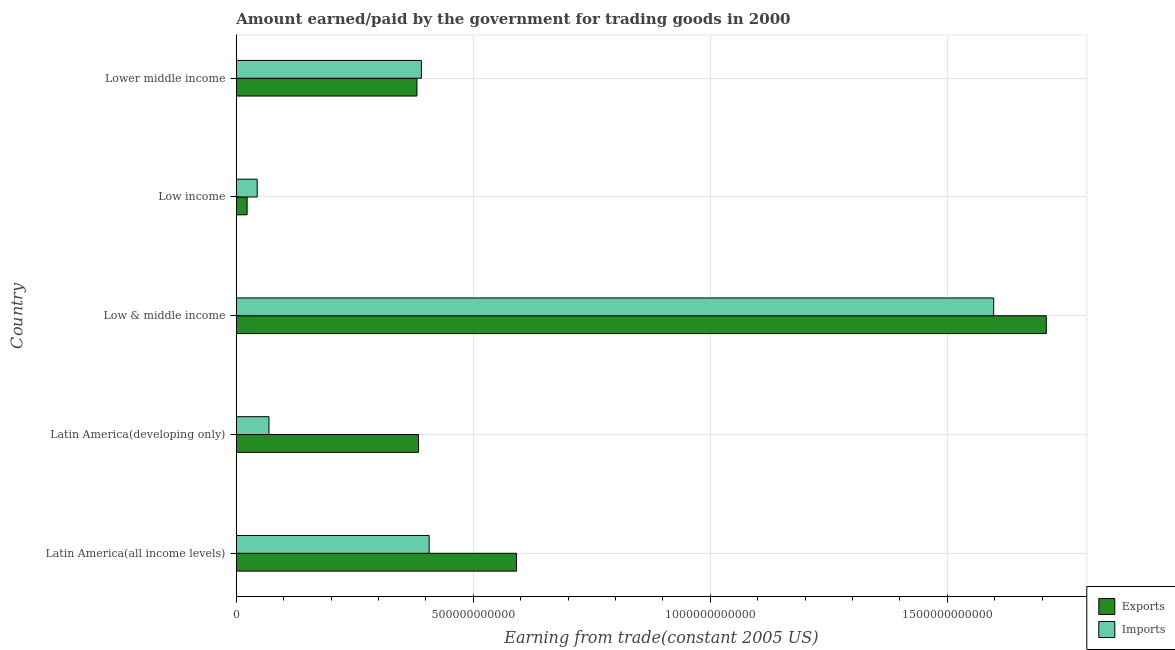How many different coloured bars are there?
Make the answer very short. 2. Are the number of bars on each tick of the Y-axis equal?
Offer a very short reply. Yes. How many bars are there on the 2nd tick from the top?
Provide a succinct answer. 2. How many bars are there on the 5th tick from the bottom?
Offer a very short reply. 2. What is the label of the 1st group of bars from the top?
Ensure brevity in your answer.  Lower middle income. What is the amount earned from exports in Latin America(all income levels)?
Offer a terse response. 5.91e+11. Across all countries, what is the maximum amount earned from exports?
Offer a terse response. 1.71e+12. Across all countries, what is the minimum amount paid for imports?
Your answer should be compact. 4.42e+1. In which country was the amount paid for imports maximum?
Keep it short and to the point. Low & middle income. What is the total amount paid for imports in the graph?
Ensure brevity in your answer.  2.51e+12. What is the difference between the amount earned from exports in Low & middle income and that in Low income?
Provide a short and direct response. 1.69e+12. What is the difference between the amount paid for imports in Low & middle income and the amount earned from exports in Latin America(developing only)?
Ensure brevity in your answer.  1.21e+12. What is the average amount paid for imports per country?
Keep it short and to the point. 5.02e+11. What is the difference between the amount paid for imports and amount earned from exports in Lower middle income?
Your answer should be very brief. 9.44e+09. What is the ratio of the amount earned from exports in Latin America(all income levels) to that in Low & middle income?
Offer a terse response. 0.35. What is the difference between the highest and the second highest amount earned from exports?
Provide a succinct answer. 1.12e+12. What is the difference between the highest and the lowest amount paid for imports?
Offer a very short reply. 1.55e+12. In how many countries, is the amount paid for imports greater than the average amount paid for imports taken over all countries?
Make the answer very short. 1. Is the sum of the amount earned from exports in Latin America(all income levels) and Low income greater than the maximum amount paid for imports across all countries?
Make the answer very short. No. What does the 1st bar from the top in Latin America(developing only) represents?
Offer a terse response. Imports. What does the 1st bar from the bottom in Low & middle income represents?
Your answer should be very brief. Exports. How many bars are there?
Your answer should be compact. 10. How many countries are there in the graph?
Your answer should be compact. 5. What is the difference between two consecutive major ticks on the X-axis?
Your answer should be very brief. 5.00e+11. Are the values on the major ticks of X-axis written in scientific E-notation?
Your response must be concise. No. How many legend labels are there?
Give a very brief answer. 2. How are the legend labels stacked?
Your answer should be very brief. Vertical. What is the title of the graph?
Keep it short and to the point. Amount earned/paid by the government for trading goods in 2000. Does "Old" appear as one of the legend labels in the graph?
Keep it short and to the point. No. What is the label or title of the X-axis?
Offer a terse response. Earning from trade(constant 2005 US). What is the label or title of the Y-axis?
Keep it short and to the point. Country. What is the Earning from trade(constant 2005 US) of Exports in Latin America(all income levels)?
Your answer should be very brief. 5.91e+11. What is the Earning from trade(constant 2005 US) in Imports in Latin America(all income levels)?
Offer a terse response. 4.07e+11. What is the Earning from trade(constant 2005 US) in Exports in Latin America(developing only)?
Ensure brevity in your answer.  3.84e+11. What is the Earning from trade(constant 2005 US) of Imports in Latin America(developing only)?
Provide a succinct answer. 6.90e+1. What is the Earning from trade(constant 2005 US) of Exports in Low & middle income?
Provide a short and direct response. 1.71e+12. What is the Earning from trade(constant 2005 US) of Imports in Low & middle income?
Provide a succinct answer. 1.60e+12. What is the Earning from trade(constant 2005 US) in Exports in Low income?
Your response must be concise. 2.29e+1. What is the Earning from trade(constant 2005 US) in Imports in Low income?
Your answer should be very brief. 4.42e+1. What is the Earning from trade(constant 2005 US) in Exports in Lower middle income?
Offer a very short reply. 3.81e+11. What is the Earning from trade(constant 2005 US) of Imports in Lower middle income?
Give a very brief answer. 3.91e+11. Across all countries, what is the maximum Earning from trade(constant 2005 US) of Exports?
Make the answer very short. 1.71e+12. Across all countries, what is the maximum Earning from trade(constant 2005 US) in Imports?
Your response must be concise. 1.60e+12. Across all countries, what is the minimum Earning from trade(constant 2005 US) in Exports?
Ensure brevity in your answer.  2.29e+1. Across all countries, what is the minimum Earning from trade(constant 2005 US) of Imports?
Your response must be concise. 4.42e+1. What is the total Earning from trade(constant 2005 US) in Exports in the graph?
Make the answer very short. 3.09e+12. What is the total Earning from trade(constant 2005 US) of Imports in the graph?
Give a very brief answer. 2.51e+12. What is the difference between the Earning from trade(constant 2005 US) of Exports in Latin America(all income levels) and that in Latin America(developing only)?
Offer a terse response. 2.07e+11. What is the difference between the Earning from trade(constant 2005 US) of Imports in Latin America(all income levels) and that in Latin America(developing only)?
Ensure brevity in your answer.  3.38e+11. What is the difference between the Earning from trade(constant 2005 US) of Exports in Latin America(all income levels) and that in Low & middle income?
Give a very brief answer. -1.12e+12. What is the difference between the Earning from trade(constant 2005 US) in Imports in Latin America(all income levels) and that in Low & middle income?
Your answer should be compact. -1.19e+12. What is the difference between the Earning from trade(constant 2005 US) in Exports in Latin America(all income levels) and that in Low income?
Ensure brevity in your answer.  5.68e+11. What is the difference between the Earning from trade(constant 2005 US) in Imports in Latin America(all income levels) and that in Low income?
Give a very brief answer. 3.63e+11. What is the difference between the Earning from trade(constant 2005 US) of Exports in Latin America(all income levels) and that in Lower middle income?
Your answer should be compact. 2.10e+11. What is the difference between the Earning from trade(constant 2005 US) in Imports in Latin America(all income levels) and that in Lower middle income?
Provide a succinct answer. 1.64e+1. What is the difference between the Earning from trade(constant 2005 US) in Exports in Latin America(developing only) and that in Low & middle income?
Provide a succinct answer. -1.32e+12. What is the difference between the Earning from trade(constant 2005 US) of Imports in Latin America(developing only) and that in Low & middle income?
Give a very brief answer. -1.53e+12. What is the difference between the Earning from trade(constant 2005 US) in Exports in Latin America(developing only) and that in Low income?
Provide a short and direct response. 3.62e+11. What is the difference between the Earning from trade(constant 2005 US) of Imports in Latin America(developing only) and that in Low income?
Your answer should be very brief. 2.48e+1. What is the difference between the Earning from trade(constant 2005 US) in Exports in Latin America(developing only) and that in Lower middle income?
Your response must be concise. 3.31e+09. What is the difference between the Earning from trade(constant 2005 US) in Imports in Latin America(developing only) and that in Lower middle income?
Your answer should be very brief. -3.22e+11. What is the difference between the Earning from trade(constant 2005 US) in Exports in Low & middle income and that in Low income?
Your response must be concise. 1.69e+12. What is the difference between the Earning from trade(constant 2005 US) of Imports in Low & middle income and that in Low income?
Ensure brevity in your answer.  1.55e+12. What is the difference between the Earning from trade(constant 2005 US) of Exports in Low & middle income and that in Lower middle income?
Offer a very short reply. 1.33e+12. What is the difference between the Earning from trade(constant 2005 US) in Imports in Low & middle income and that in Lower middle income?
Provide a succinct answer. 1.21e+12. What is the difference between the Earning from trade(constant 2005 US) of Exports in Low income and that in Lower middle income?
Your answer should be very brief. -3.58e+11. What is the difference between the Earning from trade(constant 2005 US) in Imports in Low income and that in Lower middle income?
Make the answer very short. -3.46e+11. What is the difference between the Earning from trade(constant 2005 US) in Exports in Latin America(all income levels) and the Earning from trade(constant 2005 US) in Imports in Latin America(developing only)?
Provide a succinct answer. 5.22e+11. What is the difference between the Earning from trade(constant 2005 US) in Exports in Latin America(all income levels) and the Earning from trade(constant 2005 US) in Imports in Low & middle income?
Your answer should be very brief. -1.01e+12. What is the difference between the Earning from trade(constant 2005 US) of Exports in Latin America(all income levels) and the Earning from trade(constant 2005 US) of Imports in Low income?
Provide a succinct answer. 5.47e+11. What is the difference between the Earning from trade(constant 2005 US) of Exports in Latin America(all income levels) and the Earning from trade(constant 2005 US) of Imports in Lower middle income?
Give a very brief answer. 2.01e+11. What is the difference between the Earning from trade(constant 2005 US) of Exports in Latin America(developing only) and the Earning from trade(constant 2005 US) of Imports in Low & middle income?
Offer a terse response. -1.21e+12. What is the difference between the Earning from trade(constant 2005 US) of Exports in Latin America(developing only) and the Earning from trade(constant 2005 US) of Imports in Low income?
Make the answer very short. 3.40e+11. What is the difference between the Earning from trade(constant 2005 US) in Exports in Latin America(developing only) and the Earning from trade(constant 2005 US) in Imports in Lower middle income?
Your response must be concise. -6.13e+09. What is the difference between the Earning from trade(constant 2005 US) in Exports in Low & middle income and the Earning from trade(constant 2005 US) in Imports in Low income?
Make the answer very short. 1.66e+12. What is the difference between the Earning from trade(constant 2005 US) of Exports in Low & middle income and the Earning from trade(constant 2005 US) of Imports in Lower middle income?
Make the answer very short. 1.32e+12. What is the difference between the Earning from trade(constant 2005 US) in Exports in Low income and the Earning from trade(constant 2005 US) in Imports in Lower middle income?
Make the answer very short. -3.68e+11. What is the average Earning from trade(constant 2005 US) in Exports per country?
Provide a short and direct response. 6.18e+11. What is the average Earning from trade(constant 2005 US) of Imports per country?
Make the answer very short. 5.02e+11. What is the difference between the Earning from trade(constant 2005 US) in Exports and Earning from trade(constant 2005 US) in Imports in Latin America(all income levels)?
Your answer should be compact. 1.84e+11. What is the difference between the Earning from trade(constant 2005 US) in Exports and Earning from trade(constant 2005 US) in Imports in Latin America(developing only)?
Keep it short and to the point. 3.15e+11. What is the difference between the Earning from trade(constant 2005 US) in Exports and Earning from trade(constant 2005 US) in Imports in Low & middle income?
Your answer should be compact. 1.11e+11. What is the difference between the Earning from trade(constant 2005 US) of Exports and Earning from trade(constant 2005 US) of Imports in Low income?
Offer a terse response. -2.12e+1. What is the difference between the Earning from trade(constant 2005 US) of Exports and Earning from trade(constant 2005 US) of Imports in Lower middle income?
Give a very brief answer. -9.44e+09. What is the ratio of the Earning from trade(constant 2005 US) in Exports in Latin America(all income levels) to that in Latin America(developing only)?
Provide a succinct answer. 1.54. What is the ratio of the Earning from trade(constant 2005 US) of Imports in Latin America(all income levels) to that in Latin America(developing only)?
Offer a very short reply. 5.9. What is the ratio of the Earning from trade(constant 2005 US) of Exports in Latin America(all income levels) to that in Low & middle income?
Your answer should be very brief. 0.35. What is the ratio of the Earning from trade(constant 2005 US) of Imports in Latin America(all income levels) to that in Low & middle income?
Your response must be concise. 0.25. What is the ratio of the Earning from trade(constant 2005 US) in Exports in Latin America(all income levels) to that in Low income?
Provide a short and direct response. 25.78. What is the ratio of the Earning from trade(constant 2005 US) of Imports in Latin America(all income levels) to that in Low income?
Keep it short and to the point. 9.21. What is the ratio of the Earning from trade(constant 2005 US) of Exports in Latin America(all income levels) to that in Lower middle income?
Offer a very short reply. 1.55. What is the ratio of the Earning from trade(constant 2005 US) of Imports in Latin America(all income levels) to that in Lower middle income?
Provide a succinct answer. 1.04. What is the ratio of the Earning from trade(constant 2005 US) in Exports in Latin America(developing only) to that in Low & middle income?
Offer a very short reply. 0.23. What is the ratio of the Earning from trade(constant 2005 US) of Imports in Latin America(developing only) to that in Low & middle income?
Ensure brevity in your answer.  0.04. What is the ratio of the Earning from trade(constant 2005 US) in Exports in Latin America(developing only) to that in Low income?
Your answer should be very brief. 16.76. What is the ratio of the Earning from trade(constant 2005 US) of Imports in Latin America(developing only) to that in Low income?
Provide a short and direct response. 1.56. What is the ratio of the Earning from trade(constant 2005 US) in Exports in Latin America(developing only) to that in Lower middle income?
Keep it short and to the point. 1.01. What is the ratio of the Earning from trade(constant 2005 US) in Imports in Latin America(developing only) to that in Lower middle income?
Offer a very short reply. 0.18. What is the ratio of the Earning from trade(constant 2005 US) in Exports in Low & middle income to that in Low income?
Make the answer very short. 74.51. What is the ratio of the Earning from trade(constant 2005 US) in Imports in Low & middle income to that in Low income?
Give a very brief answer. 36.17. What is the ratio of the Earning from trade(constant 2005 US) of Exports in Low & middle income to that in Lower middle income?
Give a very brief answer. 4.48. What is the ratio of the Earning from trade(constant 2005 US) in Imports in Low & middle income to that in Lower middle income?
Give a very brief answer. 4.09. What is the ratio of the Earning from trade(constant 2005 US) of Exports in Low income to that in Lower middle income?
Your answer should be compact. 0.06. What is the ratio of the Earning from trade(constant 2005 US) in Imports in Low income to that in Lower middle income?
Keep it short and to the point. 0.11. What is the difference between the highest and the second highest Earning from trade(constant 2005 US) in Exports?
Offer a terse response. 1.12e+12. What is the difference between the highest and the second highest Earning from trade(constant 2005 US) of Imports?
Your answer should be compact. 1.19e+12. What is the difference between the highest and the lowest Earning from trade(constant 2005 US) of Exports?
Your answer should be very brief. 1.69e+12. What is the difference between the highest and the lowest Earning from trade(constant 2005 US) in Imports?
Offer a terse response. 1.55e+12. 